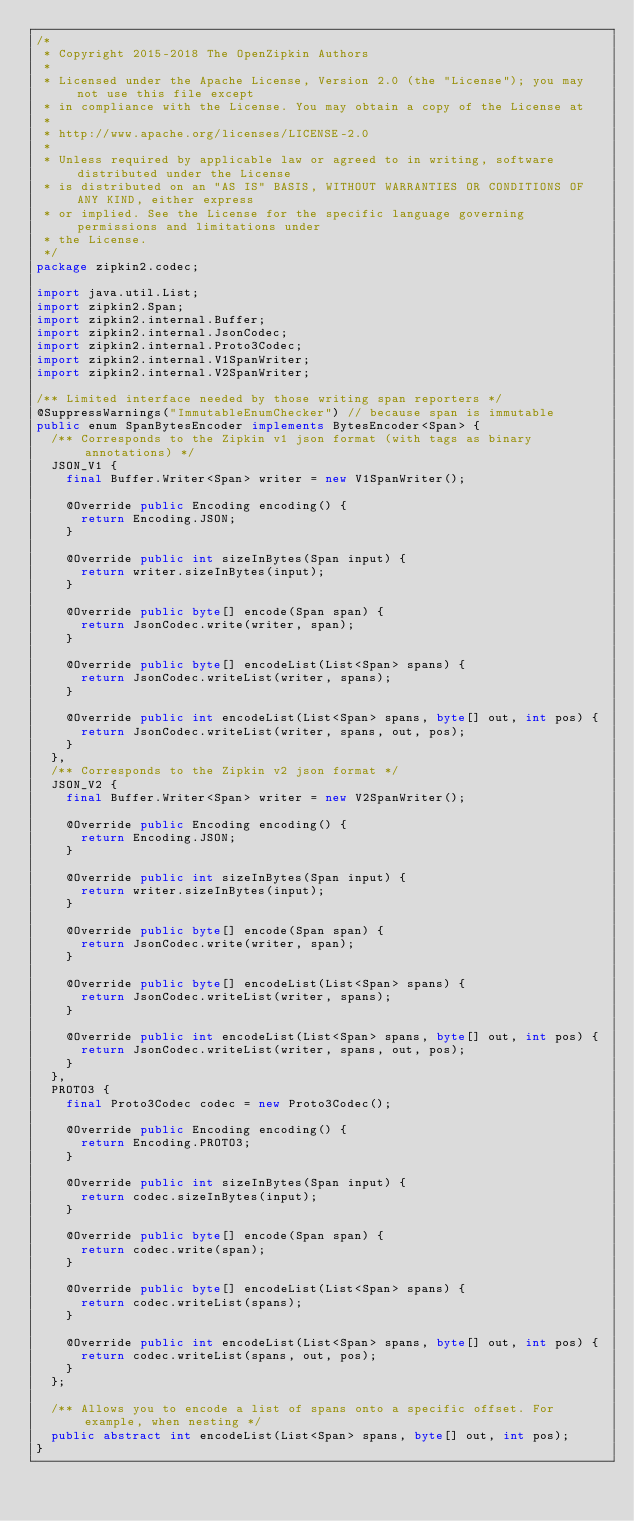<code> <loc_0><loc_0><loc_500><loc_500><_Java_>/*
 * Copyright 2015-2018 The OpenZipkin Authors
 *
 * Licensed under the Apache License, Version 2.0 (the "License"); you may not use this file except
 * in compliance with the License. You may obtain a copy of the License at
 *
 * http://www.apache.org/licenses/LICENSE-2.0
 *
 * Unless required by applicable law or agreed to in writing, software distributed under the License
 * is distributed on an "AS IS" BASIS, WITHOUT WARRANTIES OR CONDITIONS OF ANY KIND, either express
 * or implied. See the License for the specific language governing permissions and limitations under
 * the License.
 */
package zipkin2.codec;

import java.util.List;
import zipkin2.Span;
import zipkin2.internal.Buffer;
import zipkin2.internal.JsonCodec;
import zipkin2.internal.Proto3Codec;
import zipkin2.internal.V1SpanWriter;
import zipkin2.internal.V2SpanWriter;

/** Limited interface needed by those writing span reporters */
@SuppressWarnings("ImmutableEnumChecker") // because span is immutable
public enum SpanBytesEncoder implements BytesEncoder<Span> {
  /** Corresponds to the Zipkin v1 json format (with tags as binary annotations) */
  JSON_V1 {
    final Buffer.Writer<Span> writer = new V1SpanWriter();

    @Override public Encoding encoding() {
      return Encoding.JSON;
    }

    @Override public int sizeInBytes(Span input) {
      return writer.sizeInBytes(input);
    }

    @Override public byte[] encode(Span span) {
      return JsonCodec.write(writer, span);
    }

    @Override public byte[] encodeList(List<Span> spans) {
      return JsonCodec.writeList(writer, spans);
    }

    @Override public int encodeList(List<Span> spans, byte[] out, int pos) {
      return JsonCodec.writeList(writer, spans, out, pos);
    }
  },
  /** Corresponds to the Zipkin v2 json format */
  JSON_V2 {
    final Buffer.Writer<Span> writer = new V2SpanWriter();

    @Override public Encoding encoding() {
      return Encoding.JSON;
    }

    @Override public int sizeInBytes(Span input) {
      return writer.sizeInBytes(input);
    }

    @Override public byte[] encode(Span span) {
      return JsonCodec.write(writer, span);
    }

    @Override public byte[] encodeList(List<Span> spans) {
      return JsonCodec.writeList(writer, spans);
    }

    @Override public int encodeList(List<Span> spans, byte[] out, int pos) {
      return JsonCodec.writeList(writer, spans, out, pos);
    }
  },
  PROTO3 {
    final Proto3Codec codec = new Proto3Codec();

    @Override public Encoding encoding() {
      return Encoding.PROTO3;
    }

    @Override public int sizeInBytes(Span input) {
      return codec.sizeInBytes(input);
    }

    @Override public byte[] encode(Span span) {
      return codec.write(span);
    }

    @Override public byte[] encodeList(List<Span> spans) {
      return codec.writeList(spans);
    }

    @Override public int encodeList(List<Span> spans, byte[] out, int pos) {
      return codec.writeList(spans, out, pos);
    }
  };

  /** Allows you to encode a list of spans onto a specific offset. For example, when nesting */
  public abstract int encodeList(List<Span> spans, byte[] out, int pos);
}
</code> 